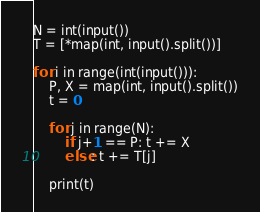Convert code to text. <code><loc_0><loc_0><loc_500><loc_500><_Python_>N = int(input())
T = [*map(int, input().split())]

for i in range(int(input())):
    P, X = map(int, input().split())
    t = 0
    
    for j in range(N):
        if j+1 == P: t += X
        else: t += T[j]
    
    print(t)</code> 